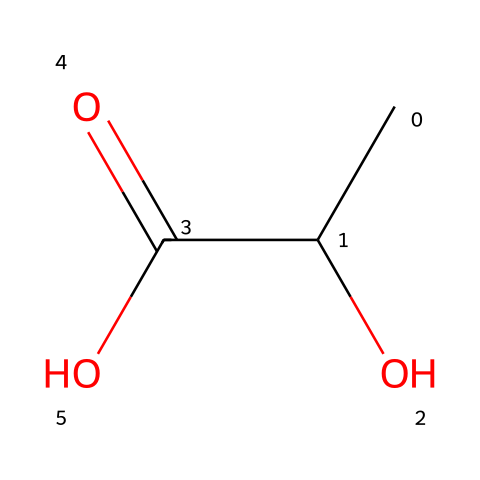What is the chemical name of the structure represented by this SMILES? The SMILES CC(O)C(=O)O corresponds to lactic acid, which is the name of the compound derived from its molecular structure.
Answer: lactic acid How many carbon atoms are present in this structure? By examining the SMILES, we see there are two 'C' characters that represent carbon atoms. Thus, there are two carbon atoms in lactic acid.
Answer: two What type of functional group is present in this molecular structure? The presence of a hydroxyl group (–OH) and a carboxylic acid group (–COOH) indicates that the primary functional group of lactic acid is a carboxylic acid.
Answer: carboxylic acid What is the total number of hydrogen atoms in this chemical structure? In the SMILES notation, there are three 'H' atoms associated with the carbon atoms directly (from the –OH and attached hydrogens), leading to a total of six hydrogen atoms in lactic acid.
Answer: six Can this chemical structure be classified as a carbene? The structure does not contain a divalent carbon atom; instead, it consists of functional groups indicating that lactic acid is an alcohol and a carboxylic acid, not a carbene.
Answer: no What type of isomerism can lactic acid exhibit? There are two forms of lactic acid, which are stereoisomers (D- and L-lactic acid), demonstrating that lactic acid can exhibit optical isomerism due to the presence of a chiral carbon atom.
Answer: optical isomerism 